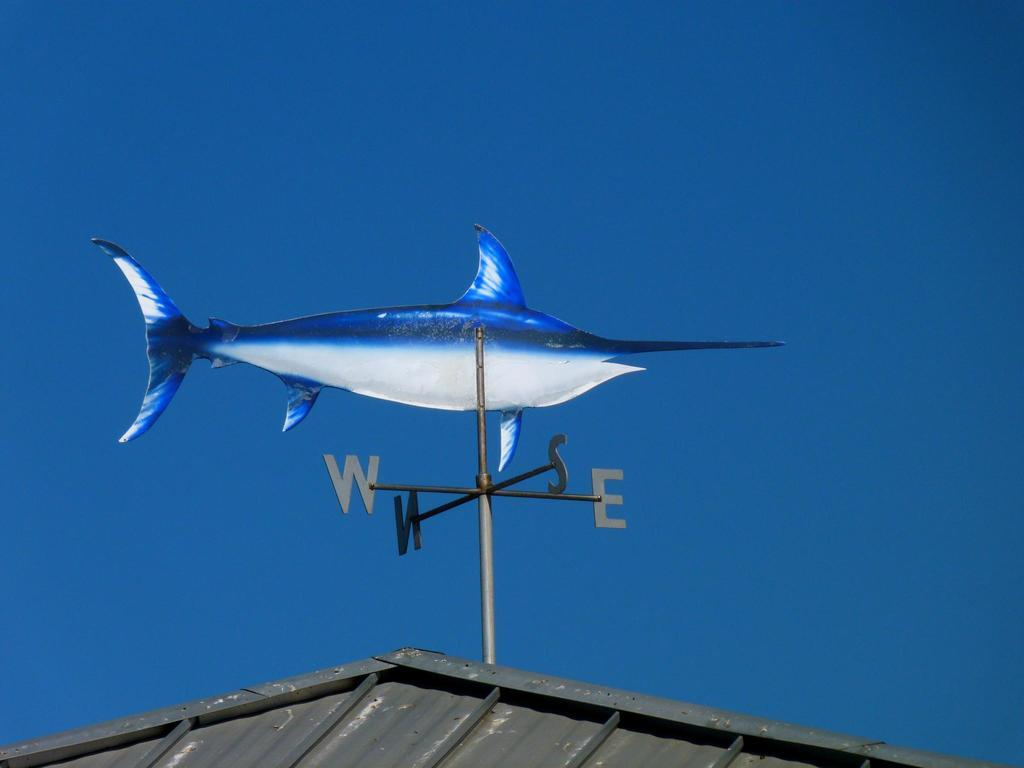What object is located on the top of the roof in the image? There is a wind vane on the top of the roof in the image. What can be seen in the background of the image? There is sky visible in the background of the image. What type of pie is being offered to the wind vane in the image? There is no pie or offering present in the image; it only features a wind vane on the roof and the sky in the background. 